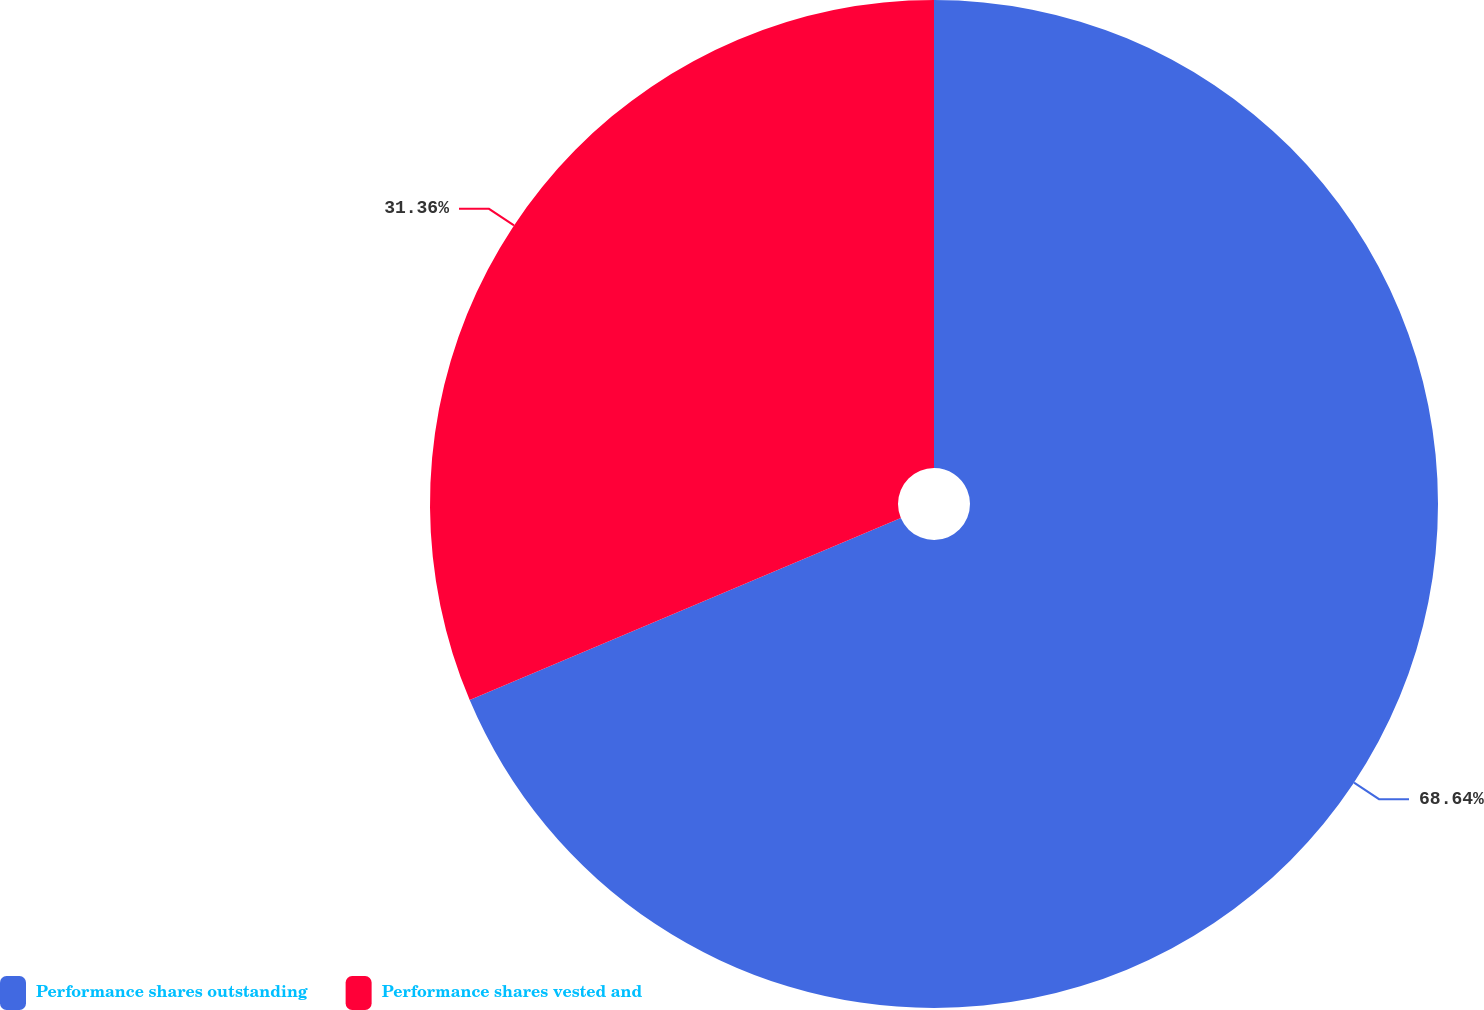<chart> <loc_0><loc_0><loc_500><loc_500><pie_chart><fcel>Performance shares outstanding<fcel>Performance shares vested and<nl><fcel>68.64%<fcel>31.36%<nl></chart> 